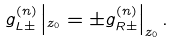Convert formula to latex. <formula><loc_0><loc_0><loc_500><loc_500>g ^ { ( n ) } _ { L \pm } \left | _ { z _ { 0 } } = \pm g ^ { ( n ) } _ { R \pm } \right | _ { z _ { 0 } } .</formula> 